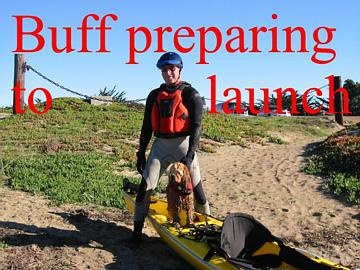Describe the objects in this image and their specific colors. I can see people in lightblue, black, maroon, gray, and navy tones, boat in lightblue, black, olive, maroon, and gray tones, and dog in lightblue, black, maroon, and gray tones in this image. 